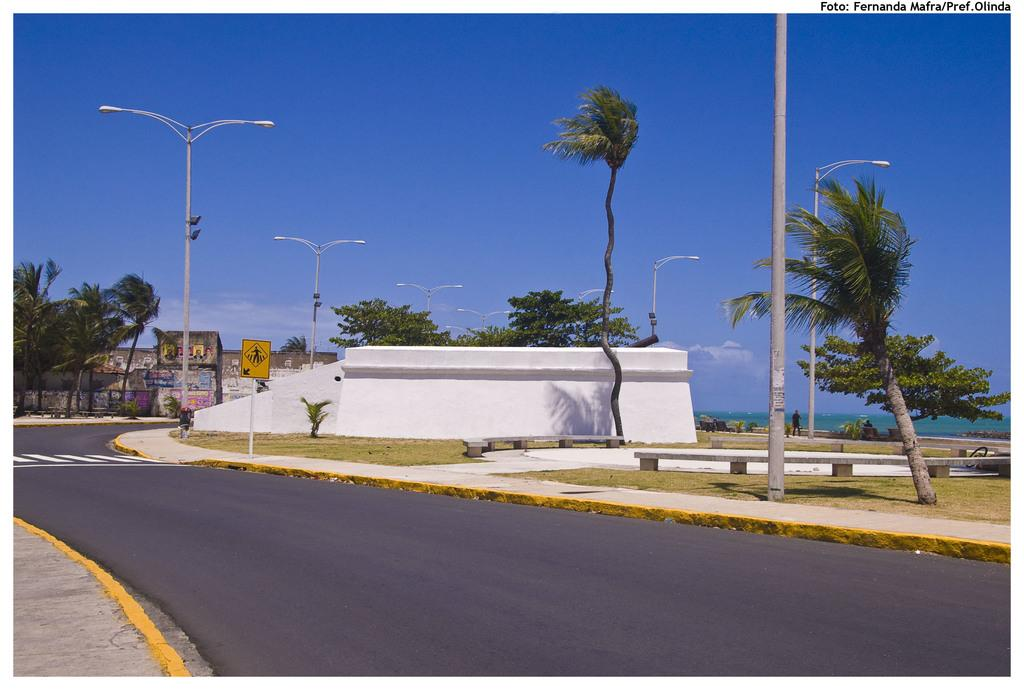What type of pathway is visible in the image? There is a road in the image. What natural elements can be seen in the image? There are trees and grass visible in the image. What type of lighting is present in the image? There are street lights in the image. What type of structure is present in the image? There is a wall in the image. What is visible in the sky in the image? There are clouds visible in the sky. What type of informational signs are present in the image? There are sign boards in the image. What type of sweater is the crook wearing in the image? There is no crook or sweater present in the image. What advice does the grandfather give to the child in the image? There is no grandfather or child present in the image. 